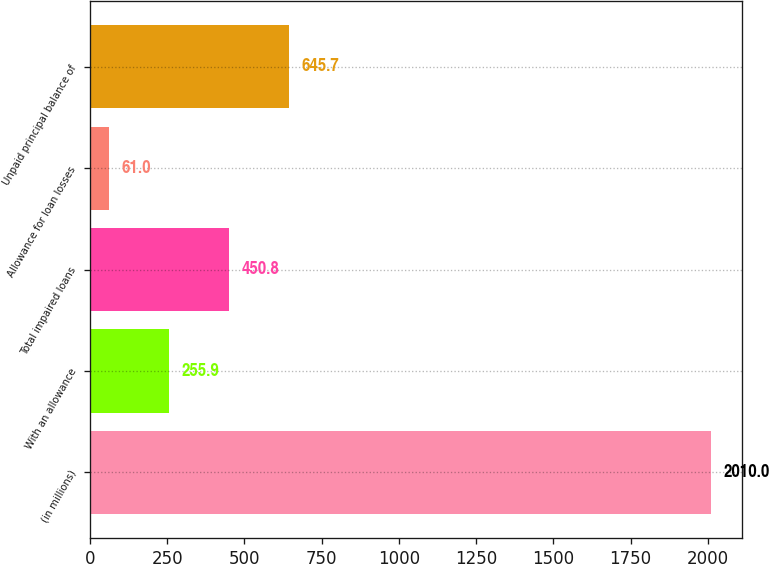Convert chart. <chart><loc_0><loc_0><loc_500><loc_500><bar_chart><fcel>(in millions)<fcel>With an allowance<fcel>Total impaired loans<fcel>Allowance for loan losses<fcel>Unpaid principal balance of<nl><fcel>2010<fcel>255.9<fcel>450.8<fcel>61<fcel>645.7<nl></chart> 